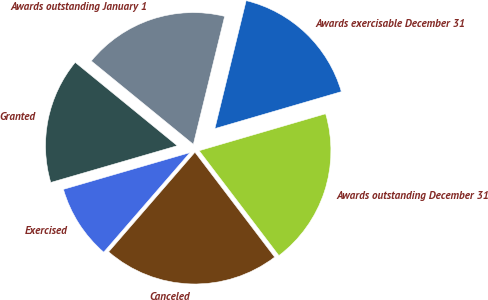Convert chart to OTSL. <chart><loc_0><loc_0><loc_500><loc_500><pie_chart><fcel>Awards outstanding January 1<fcel>Granted<fcel>Exercised<fcel>Canceled<fcel>Awards outstanding December 31<fcel>Awards exercisable December 31<nl><fcel>17.92%<fcel>15.4%<fcel>9.14%<fcel>21.71%<fcel>19.18%<fcel>16.66%<nl></chart> 